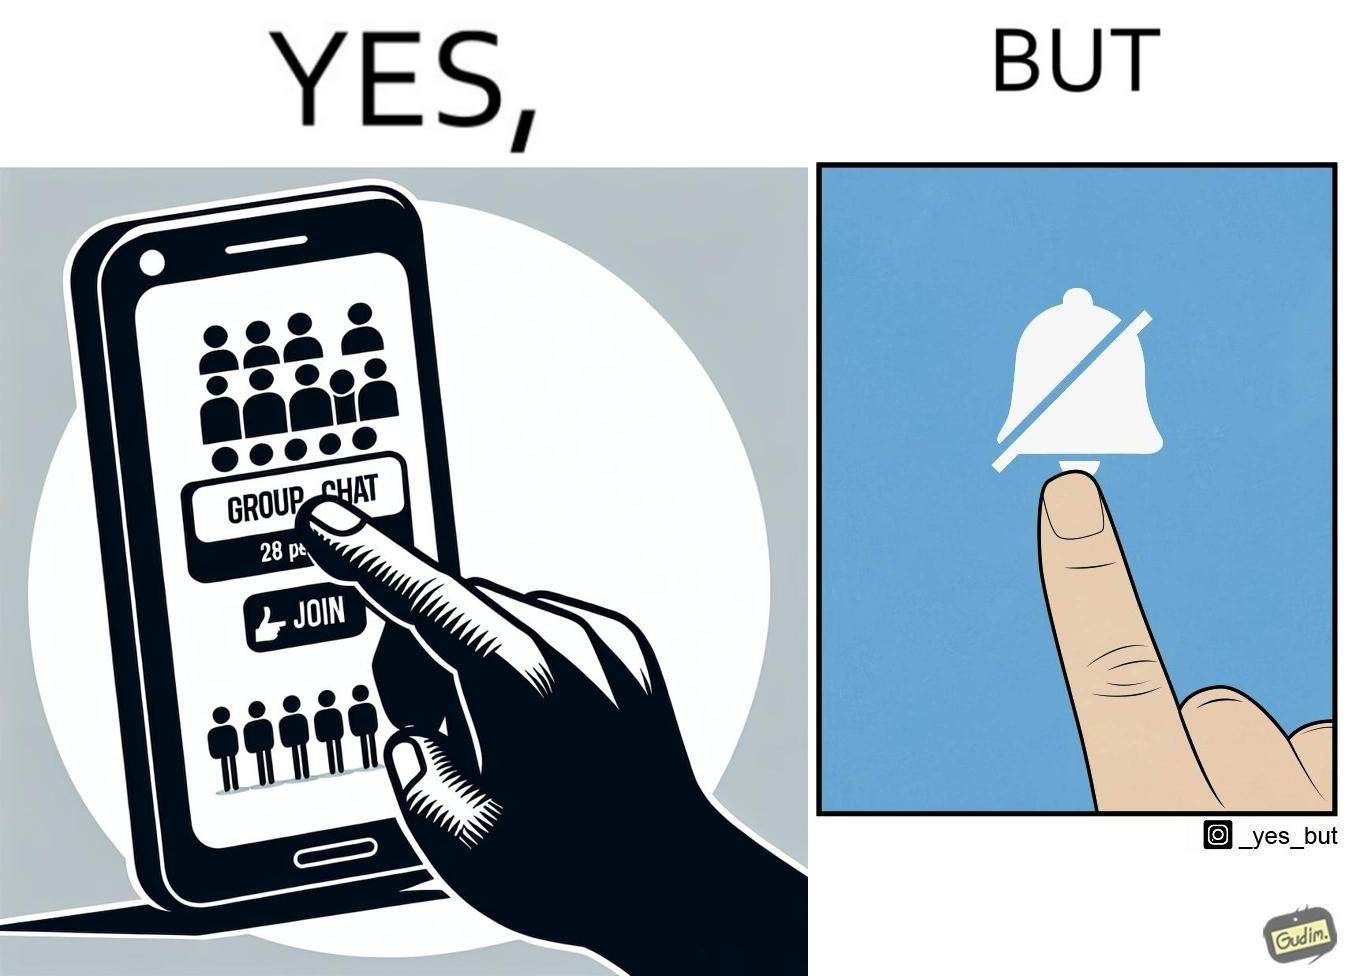Would you classify this image as satirical? Yes, this image is satirical. 